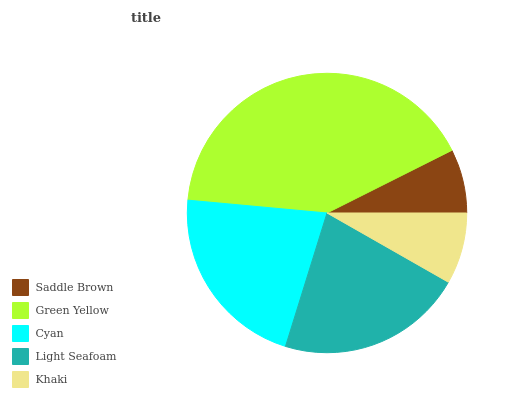Is Saddle Brown the minimum?
Answer yes or no. Yes. Is Green Yellow the maximum?
Answer yes or no. Yes. Is Cyan the minimum?
Answer yes or no. No. Is Cyan the maximum?
Answer yes or no. No. Is Green Yellow greater than Cyan?
Answer yes or no. Yes. Is Cyan less than Green Yellow?
Answer yes or no. Yes. Is Cyan greater than Green Yellow?
Answer yes or no. No. Is Green Yellow less than Cyan?
Answer yes or no. No. Is Light Seafoam the high median?
Answer yes or no. Yes. Is Light Seafoam the low median?
Answer yes or no. Yes. Is Saddle Brown the high median?
Answer yes or no. No. Is Saddle Brown the low median?
Answer yes or no. No. 